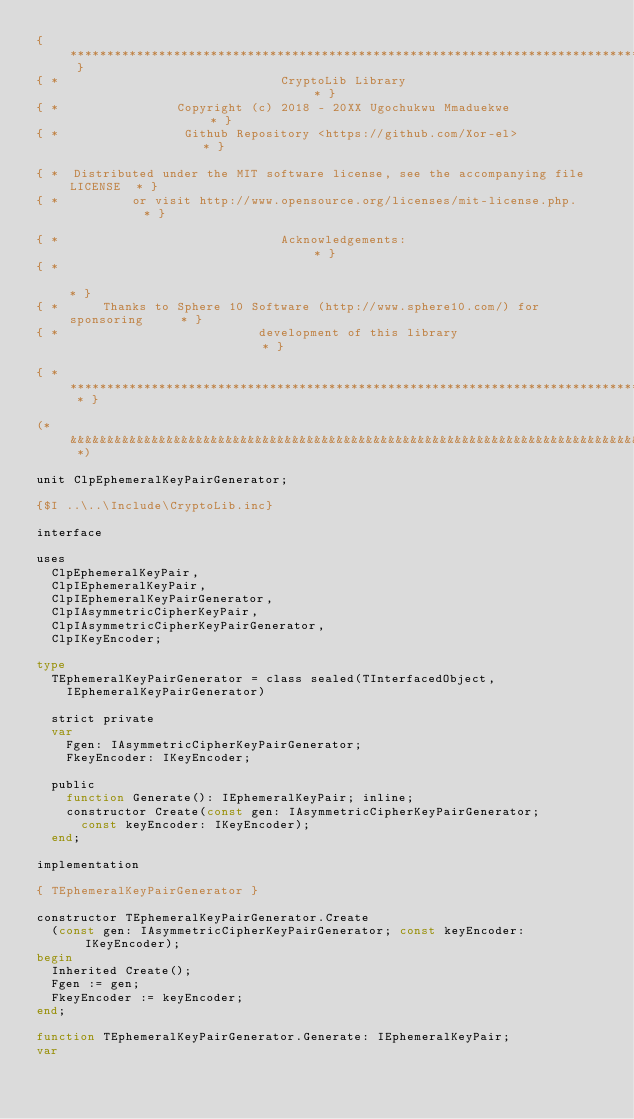Convert code to text. <code><loc_0><loc_0><loc_500><loc_500><_Pascal_>{ *********************************************************************************** }
{ *                              CryptoLib Library                                  * }
{ *                Copyright (c) 2018 - 20XX Ugochukwu Mmaduekwe                    * }
{ *                 Github Repository <https://github.com/Xor-el>                   * }

{ *  Distributed under the MIT software license, see the accompanying file LICENSE  * }
{ *          or visit http://www.opensource.org/licenses/mit-license.php.           * }

{ *                              Acknowledgements:                                  * }
{ *                                                                                 * }
{ *      Thanks to Sphere 10 Software (http://www.sphere10.com/) for sponsoring     * }
{ *                           development of this library                           * }

{ * ******************************************************************************* * }

(* &&&&&&&&&&&&&&&&&&&&&&&&&&&&&&&&&&&&&&&&&&&&&&&&&&&&&&&&&&&&&&&&&&&&&&&&&&&&&&&&& *)

unit ClpEphemeralKeyPairGenerator;

{$I ..\..\Include\CryptoLib.inc}

interface

uses
  ClpEphemeralKeyPair,
  ClpIEphemeralKeyPair,
  ClpIEphemeralKeyPairGenerator,
  ClpIAsymmetricCipherKeyPair,
  ClpIAsymmetricCipherKeyPairGenerator,
  ClpIKeyEncoder;

type
  TEphemeralKeyPairGenerator = class sealed(TInterfacedObject,
    IEphemeralKeyPairGenerator)

  strict private
  var
    Fgen: IAsymmetricCipherKeyPairGenerator;
    FkeyEncoder: IKeyEncoder;

  public
    function Generate(): IEphemeralKeyPair; inline;
    constructor Create(const gen: IAsymmetricCipherKeyPairGenerator;
      const keyEncoder: IKeyEncoder);
  end;

implementation

{ TEphemeralKeyPairGenerator }

constructor TEphemeralKeyPairGenerator.Create
  (const gen: IAsymmetricCipherKeyPairGenerator; const keyEncoder: IKeyEncoder);
begin
  Inherited Create();
  Fgen := gen;
  FkeyEncoder := keyEncoder;
end;

function TEphemeralKeyPairGenerator.Generate: IEphemeralKeyPair;
var</code> 